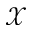Convert formula to latex. <formula><loc_0><loc_0><loc_500><loc_500>\mathcal { X }</formula> 